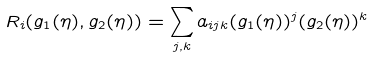Convert formula to latex. <formula><loc_0><loc_0><loc_500><loc_500>R _ { i } ( g _ { 1 } ( \eta ) , g _ { 2 } ( \eta ) ) = \sum _ { j , k } a _ { i j k } ( g _ { 1 } ( \eta ) ) ^ { j } ( g _ { 2 } ( \eta ) ) ^ { k }</formula> 